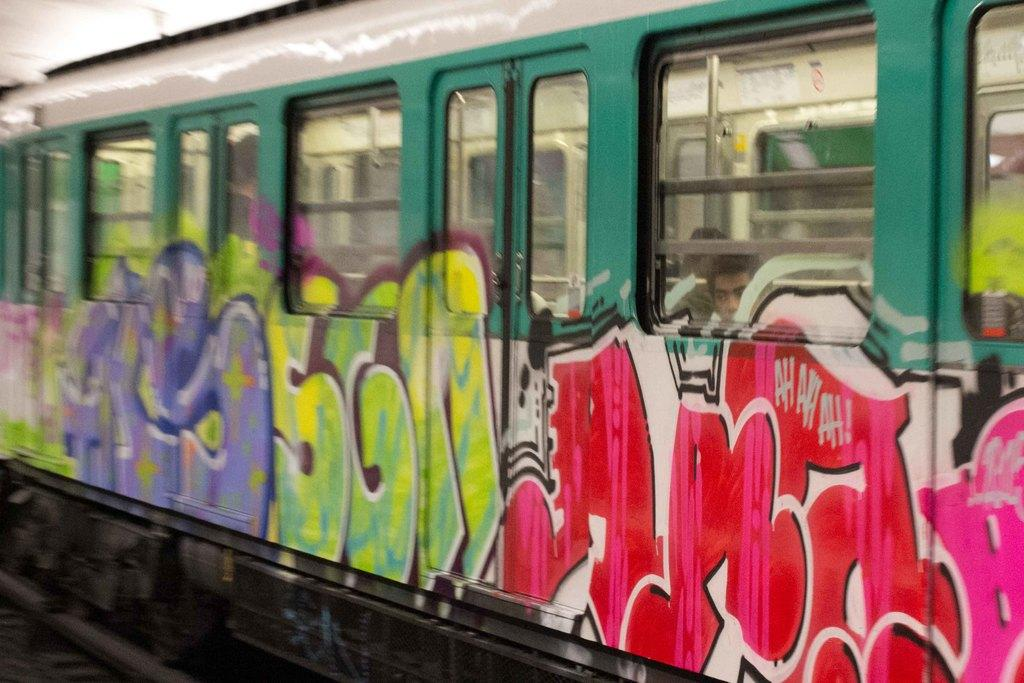What is the main subject of the image? The main subject of the image is a train. Where is the train located? The train is on a railway track. Are there any people inside the train? Yes, there are two persons inside the train. What can be seen on the exterior of the train? There is graffiti on the train. What type of apple can be seen hanging from the railway track in the image? There is no apple present in the image, and therefore no such object can be observed hanging from the railway track. 